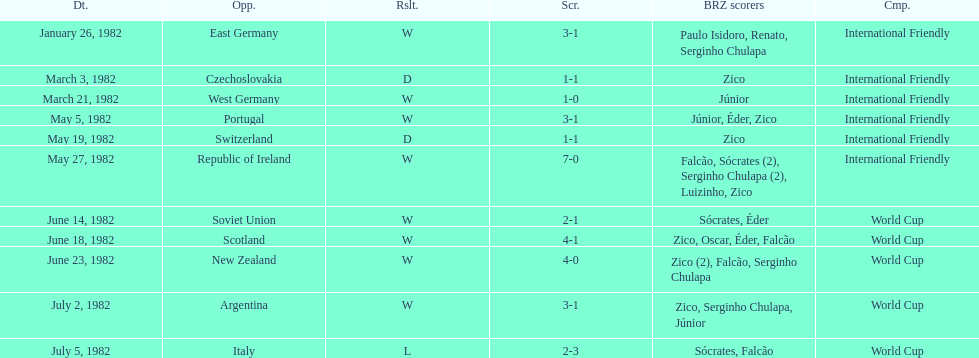How many games did this team play in 1982? 11. 